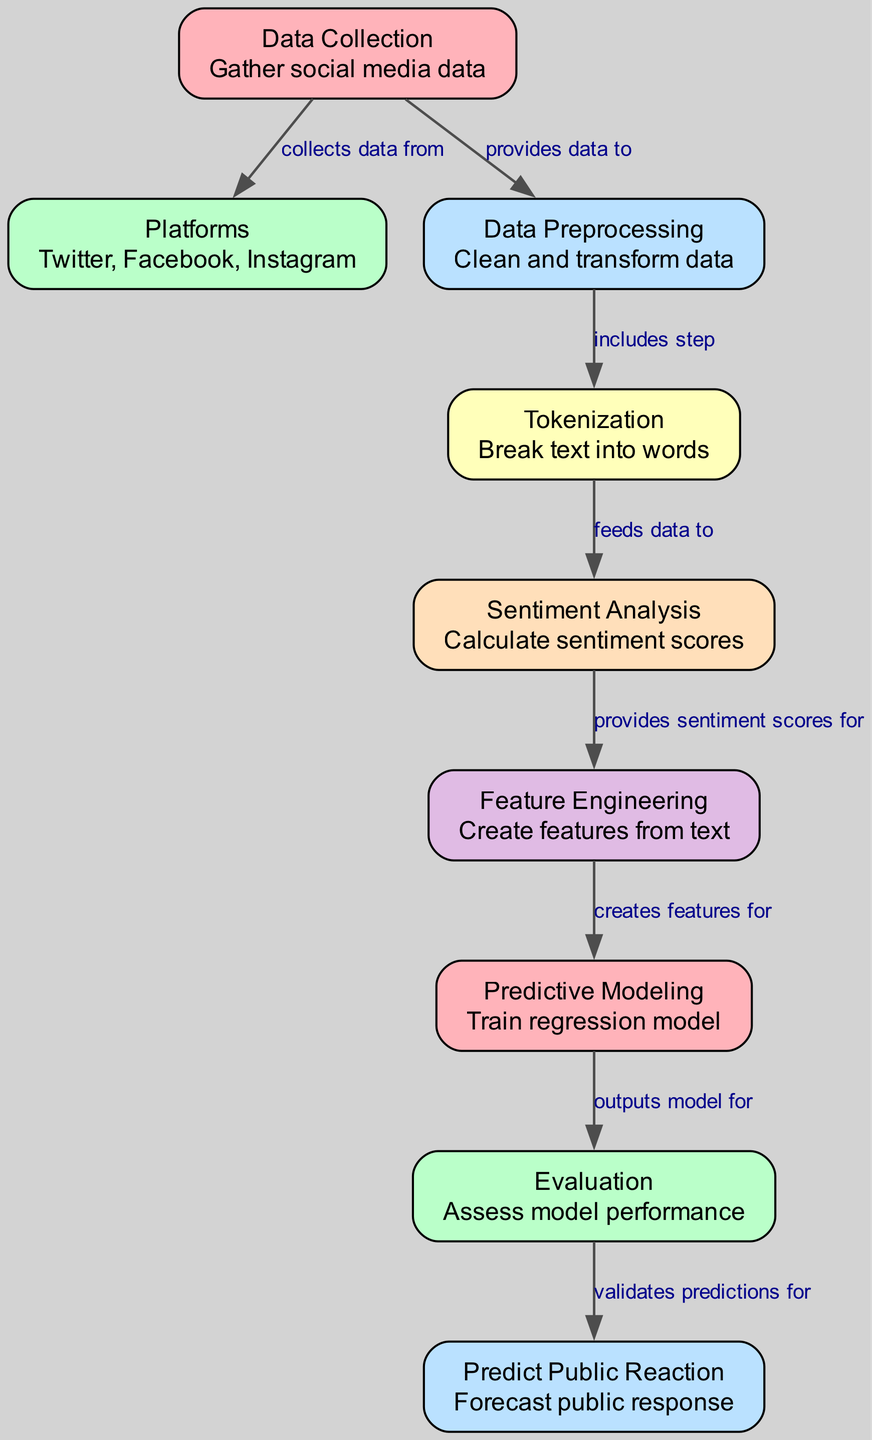What are the platforms mentioned for data collection? The diagram lists three platforms from which data is collected: Twitter, Facebook, and Instagram. This information can be found directly under the "Platforms" node.
Answer: Twitter, Facebook, Instagram How many nodes are in the diagram? By counting the 'nodes' section in the provided data, there are eight distinct nodes present in the diagram, each representing different steps in the machine learning process.
Answer: 8 What type of data is collected in the first step of the process? The very first node labeled "Data Collection" indicates that the data gathered pertains to social media, specifically noting the context of information related to current events and corporate scandals.
Answer: Social media data Which node provides data for sentiment analysis? The "Tokenization" node is directly connected to the "Sentiment Analysis" node, indicating that it is the one responsible for feeding data necessary for performing sentiment analysis on the cleaned and processed text from social media.
Answer: Tokenization What is the final output validated by the evaluation step? The "Public Reaction" node represents the final output of the whole process, indicating that this step forecasts or predicts the overall public response to corporate scandals. This is validated by the "Evaluation" node which checks the predictive accuracy.
Answer: Public response How many edges connect the nodes in the diagram? In the provided data, there are eight edges listed, each representing a directional relationship between the nodes in the process, illustrating the order and connectivity of various steps of the machine learning framework.
Answer: 8 What does the feature engineering step provide for predictive modeling? The "Feature Engineering" node supplies the "Predictive Modeling" node with created features derived from the text data, which includes sentiment scores calculated in earlier steps, effectively acting as input for the regression model training.
Answer: Features Identify a relationship between the data preprocessing and tokenization nodes. The relationship between these two nodes is that the data preprocessing step includes the tokenization process, as highlighted in the diagram’s description of the connection between the two nodes.
Answer: Includes step 